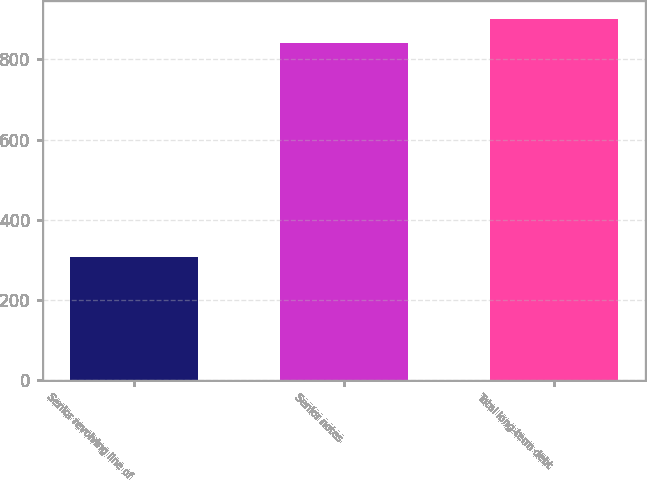Convert chart to OTSL. <chart><loc_0><loc_0><loc_500><loc_500><bar_chart><fcel>Senior revolving line of<fcel>Senior notes<fcel>Total long-term debt<nl><fcel>307.1<fcel>842<fcel>901.13<nl></chart> 